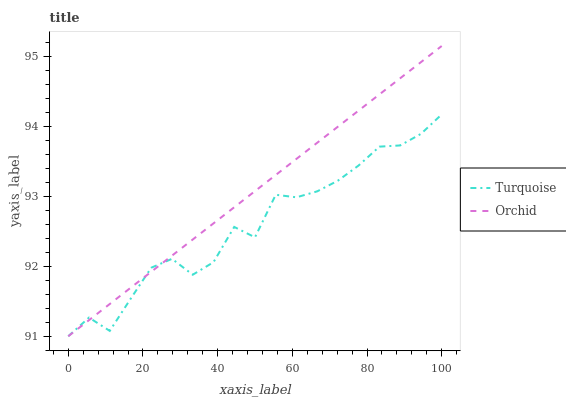Does Orchid have the minimum area under the curve?
Answer yes or no. No. Is Orchid the roughest?
Answer yes or no. No. 